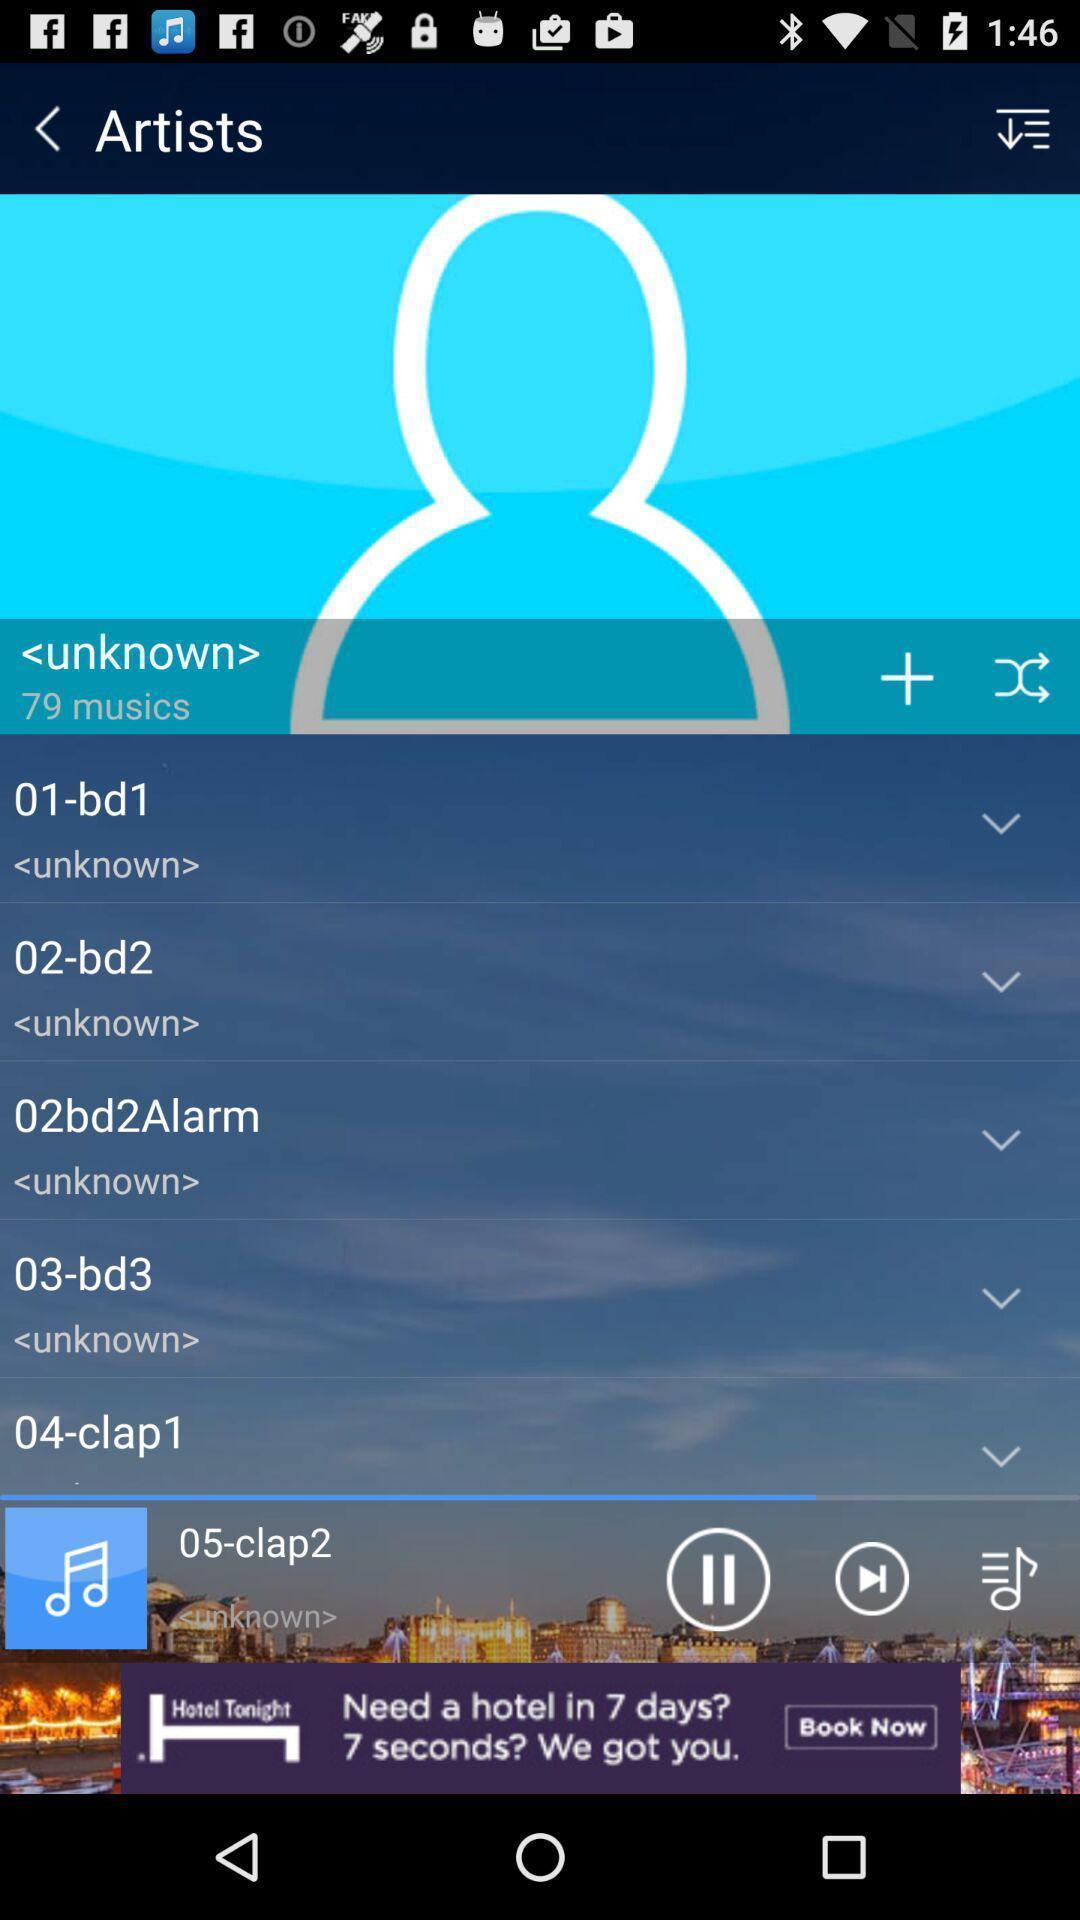Explain the elements present in this screenshot. Page displaying the setting options artists. 